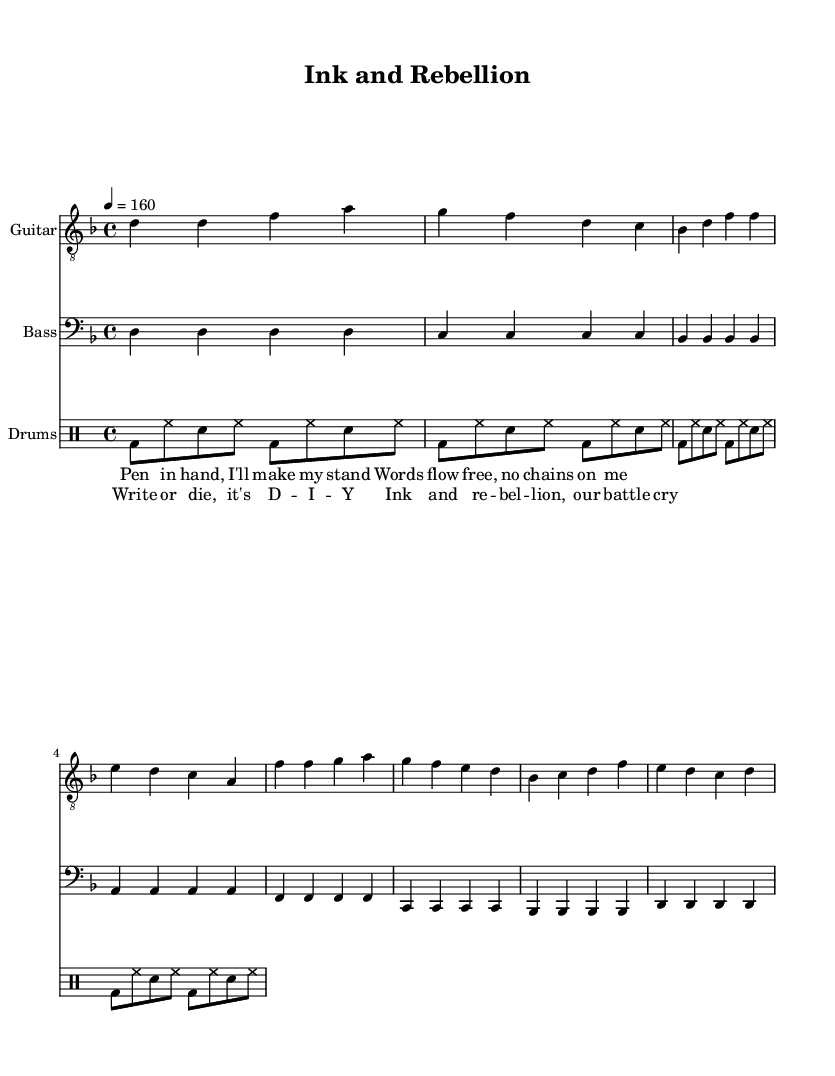What is the key signature of this music? The key signature is indicated by the notes present in the key signature section. The absence of sharps or flats next to the treble clef indicates the key of D minor, which has one flat (B flat).
Answer: D minor What is the time signature of this music? The time signature is found at the beginning of the score and shows 4/4, which means there are four beats in each measure and the quarter note gets one beat.
Answer: 4/4 What is the tempo marking of this music? The tempo marking appears at the beginning of the score, indicating how fast the music should be played. Here, it is set at quarter note equals 160 beats per minute.
Answer: 160 How many measures are in the verse section? To determine the number of measures, we count the groups separated by vertical lines in the music staff section specifically for the verse. There are four measures in the verse segment.
Answer: 4 How many notes are played in the chorus section by the guitar? By examining the notes in the chorus segment of the guitar part, we can count them. The guitar plays eight notes in the chorus section.
Answer: 8 What is the predominant rhythm used in the drums? The drum part contains a repeating pattern emphasizing the bass drum and snare with hi-hat accents, which is characteristic of punk music. This basic punk beat typically cycles through eighth notes with strong accents typical in punk songs.
Answer: Basic punk beat What is the main lyrical theme of this song? The lyrics express themes of self-expression and rebellion, emphasizing the importance of writing and individuality through the lines provided in the verse and chorus. Self-empowerment is a core theme.
Answer: Self-expression 